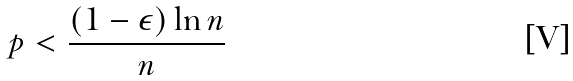Convert formula to latex. <formula><loc_0><loc_0><loc_500><loc_500>p < \frac { ( 1 - \epsilon ) \ln n } { n }</formula> 